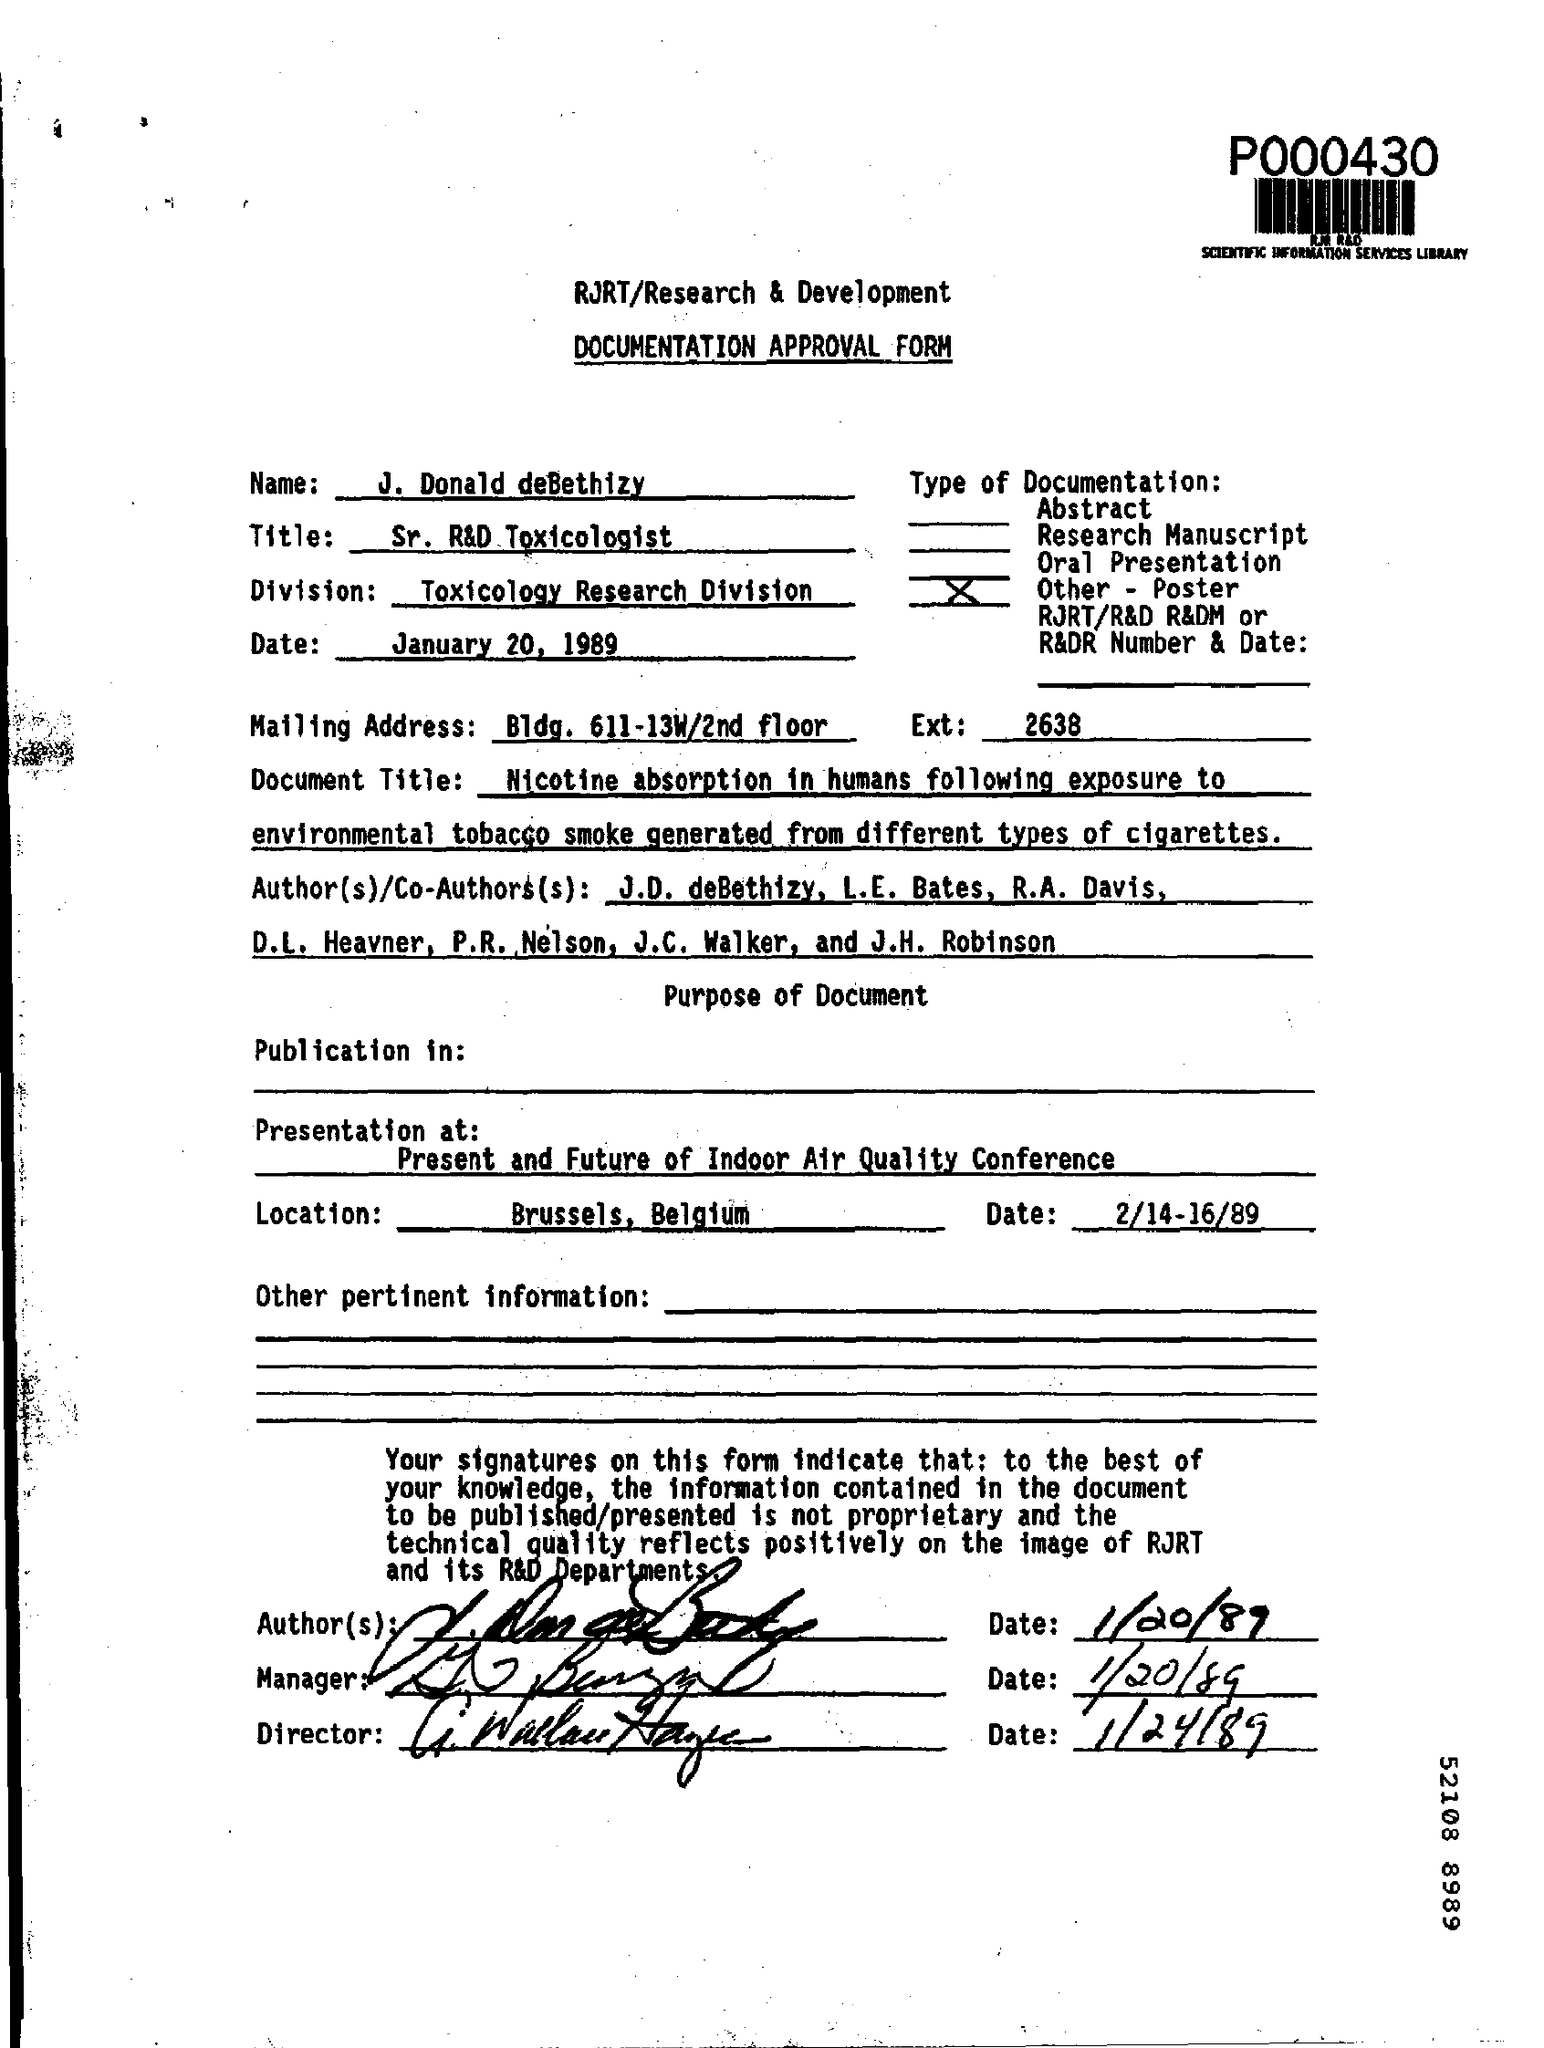List a handful of essential elements in this visual. The Presentation is being held at the Present and Future of Indoor Air Quality Conference. The conference is being held in Brussels, Belgium. The form provided is a documentation approval form. When is the conference scheduled to take place? It is scheduled for February 14-16 of 1989. John Donald deBethizy works in the Toxicology Research Division. 